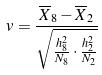Convert formula to latex. <formula><loc_0><loc_0><loc_500><loc_500>v = \frac { \overline { X } _ { 8 } - \overline { X } _ { 2 } } { \sqrt { \frac { h _ { 8 } ^ { 2 } } { N _ { 8 } } \cdot \frac { h _ { 2 } ^ { 2 } } { N _ { 2 } } } }</formula> 